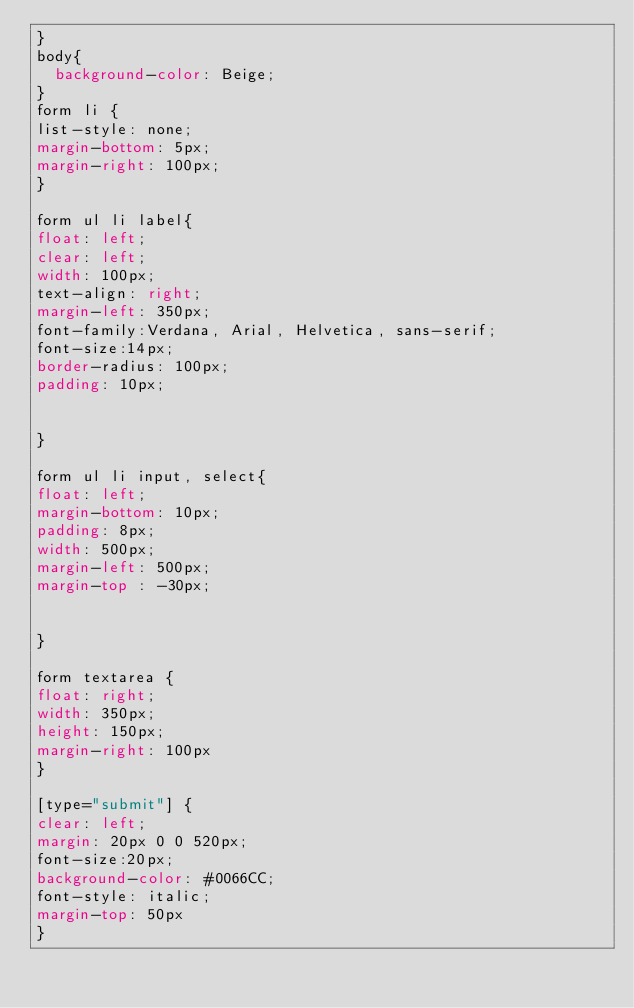<code> <loc_0><loc_0><loc_500><loc_500><_CSS_>}
body{
  background-color: Beige;
}
form li {
list-style: none;
margin-bottom: 5px;
margin-right: 100px;
}

form ul li label{
float: left;
clear: left;
width: 100px;
text-align: right;
margin-left: 350px;
font-family:Verdana, Arial, Helvetica, sans-serif;
font-size:14px;
border-radius: 100px;
padding: 10px;


}

form ul li input, select{
float: left;
margin-bottom: 10px;
padding: 8px;
width: 500px;
margin-left: 500px;
margin-top : -30px;


}

form textarea {
float: right;
width: 350px;
height: 150px;
margin-right: 100px
}

[type="submit"] {
clear: left;
margin: 20px 0 0 520px;
font-size:20px;
background-color: #0066CC;
font-style: italic;
margin-top: 50px
}

	

	
	


</code> 